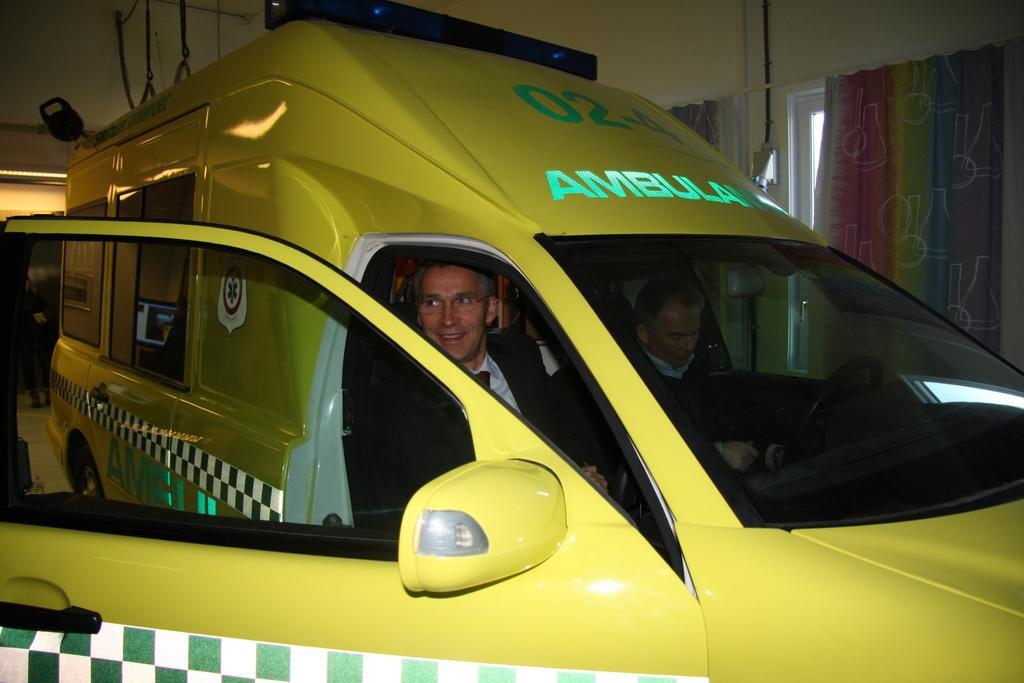Describe this image in one or two sentences. In this image I can see two people sitting in the vehicle. To the right I can see the curtains to the windows. To the left I can see one more person standing. I can see few ropes at the top. 